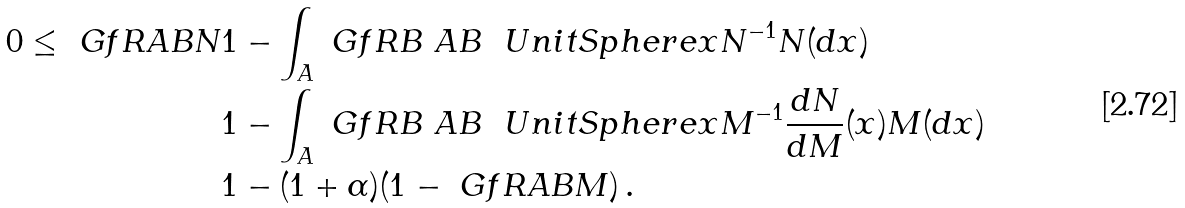<formula> <loc_0><loc_0><loc_500><loc_500>0 \leq \ G f R { A } { B } { N } & 1 - \int _ { A } \ G f R { B \ A } { B \ \ U n i t S p h e r e { x } } { N } ^ { - 1 } N ( d x ) \\ & 1 - \int _ { A } \ G f R { B \ A } { B \ \ U n i t S p h e r e { x } } { M } ^ { - 1 } \frac { d N } { d M } ( x ) M ( d x ) \\ & 1 - ( 1 + \alpha ) ( 1 - \ G f R { A } { B } { M } ) \, .</formula> 